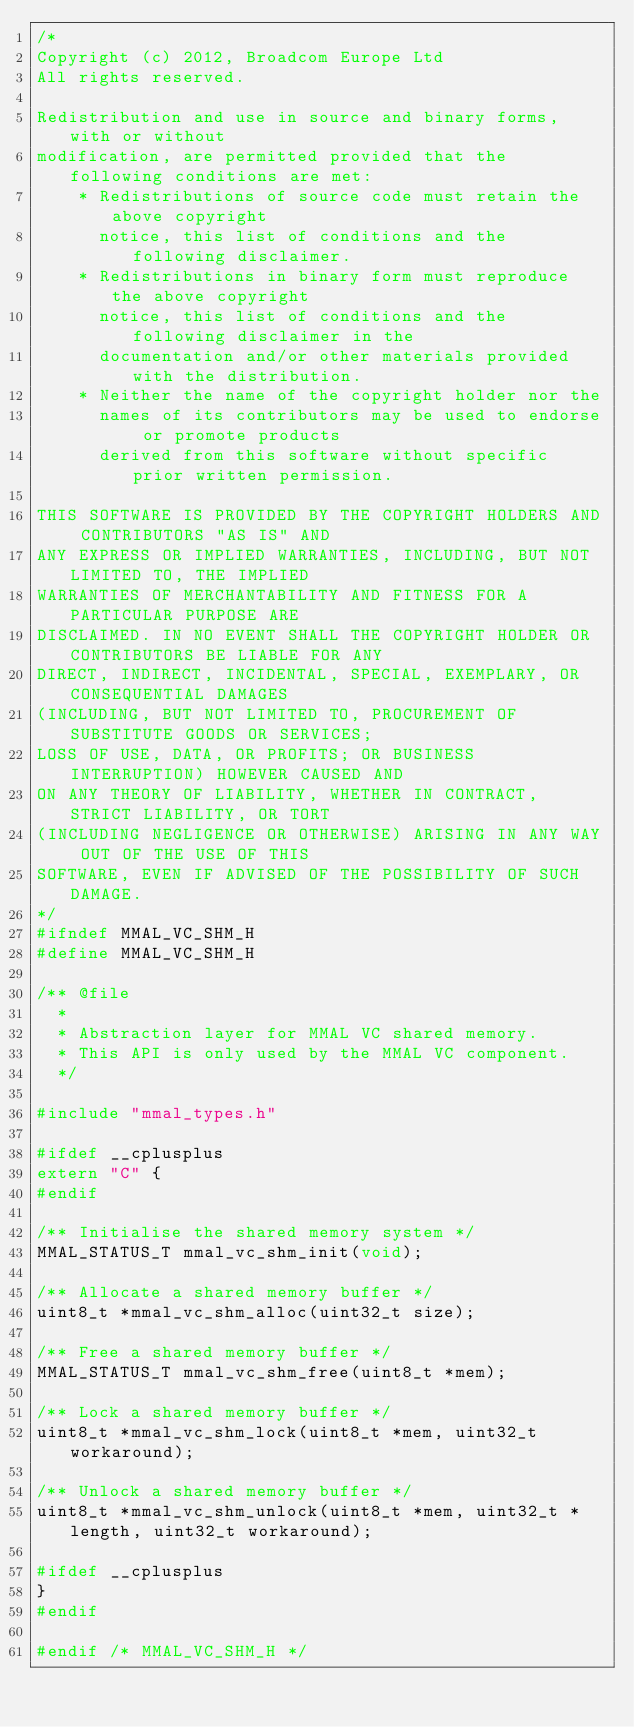<code> <loc_0><loc_0><loc_500><loc_500><_C_>/*
Copyright (c) 2012, Broadcom Europe Ltd
All rights reserved.

Redistribution and use in source and binary forms, with or without
modification, are permitted provided that the following conditions are met:
    * Redistributions of source code must retain the above copyright
      notice, this list of conditions and the following disclaimer.
    * Redistributions in binary form must reproduce the above copyright
      notice, this list of conditions and the following disclaimer in the
      documentation and/or other materials provided with the distribution.
    * Neither the name of the copyright holder nor the
      names of its contributors may be used to endorse or promote products
      derived from this software without specific prior written permission.

THIS SOFTWARE IS PROVIDED BY THE COPYRIGHT HOLDERS AND CONTRIBUTORS "AS IS" AND
ANY EXPRESS OR IMPLIED WARRANTIES, INCLUDING, BUT NOT LIMITED TO, THE IMPLIED
WARRANTIES OF MERCHANTABILITY AND FITNESS FOR A PARTICULAR PURPOSE ARE
DISCLAIMED. IN NO EVENT SHALL THE COPYRIGHT HOLDER OR CONTRIBUTORS BE LIABLE FOR ANY
DIRECT, INDIRECT, INCIDENTAL, SPECIAL, EXEMPLARY, OR CONSEQUENTIAL DAMAGES
(INCLUDING, BUT NOT LIMITED TO, PROCUREMENT OF SUBSTITUTE GOODS OR SERVICES;
LOSS OF USE, DATA, OR PROFITS; OR BUSINESS INTERRUPTION) HOWEVER CAUSED AND
ON ANY THEORY OF LIABILITY, WHETHER IN CONTRACT, STRICT LIABILITY, OR TORT
(INCLUDING NEGLIGENCE OR OTHERWISE) ARISING IN ANY WAY OUT OF THE USE OF THIS
SOFTWARE, EVEN IF ADVISED OF THE POSSIBILITY OF SUCH DAMAGE.
*/
#ifndef MMAL_VC_SHM_H
#define MMAL_VC_SHM_H

/** @file
  *
  * Abstraction layer for MMAL VC shared memory.
  * This API is only used by the MMAL VC component.
  */

#include "mmal_types.h"

#ifdef __cplusplus
extern "C" {
#endif

/** Initialise the shared memory system */
MMAL_STATUS_T mmal_vc_shm_init(void);

/** Allocate a shared memory buffer */
uint8_t *mmal_vc_shm_alloc(uint32_t size);

/** Free a shared memory buffer */
MMAL_STATUS_T mmal_vc_shm_free(uint8_t *mem);

/** Lock a shared memory buffer */
uint8_t *mmal_vc_shm_lock(uint8_t *mem, uint32_t workaround);

/** Unlock a shared memory buffer */
uint8_t *mmal_vc_shm_unlock(uint8_t *mem, uint32_t *length, uint32_t workaround);

#ifdef __cplusplus
}
#endif

#endif /* MMAL_VC_SHM_H */
</code> 